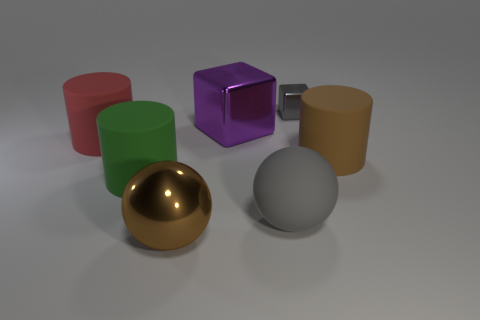How many other things are there of the same material as the small gray thing?
Offer a very short reply. 2. Are there more large yellow cylinders than large green matte cylinders?
Your response must be concise. No. There is a big metal thing that is in front of the big red object; is it the same color as the small metallic cube?
Offer a terse response. No. The large metallic sphere is what color?
Keep it short and to the point. Brown. Are there any gray cubes on the left side of the metallic thing that is behind the large purple metal cube?
Offer a very short reply. No. There is a gray thing behind the brown object that is on the right side of the metallic sphere; what is its shape?
Offer a terse response. Cube. Is the number of large brown spheres less than the number of big brown things?
Offer a very short reply. Yes. Is the material of the big green cylinder the same as the purple thing?
Your answer should be compact. No. What color is the rubber object that is both right of the red cylinder and left of the large cube?
Your response must be concise. Green. Are there any rubber spheres that have the same size as the brown metallic object?
Keep it short and to the point. Yes. 